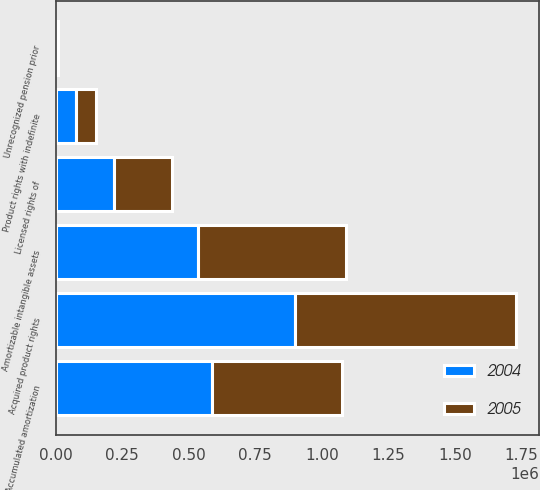<chart> <loc_0><loc_0><loc_500><loc_500><stacked_bar_chart><ecel><fcel>Acquired product rights<fcel>Licensed rights of<fcel>Accumulated amortization<fcel>Amortizable intangible assets<fcel>Product rights with indefinite<fcel>Unrecognized pension prior<nl><fcel>2004<fcel>900891<fcel>219071<fcel>586022<fcel>533940<fcel>75738<fcel>3755<nl><fcel>2005<fcel>828186<fcel>219071<fcel>489238<fcel>558019<fcel>75738<fcel>4172<nl></chart> 